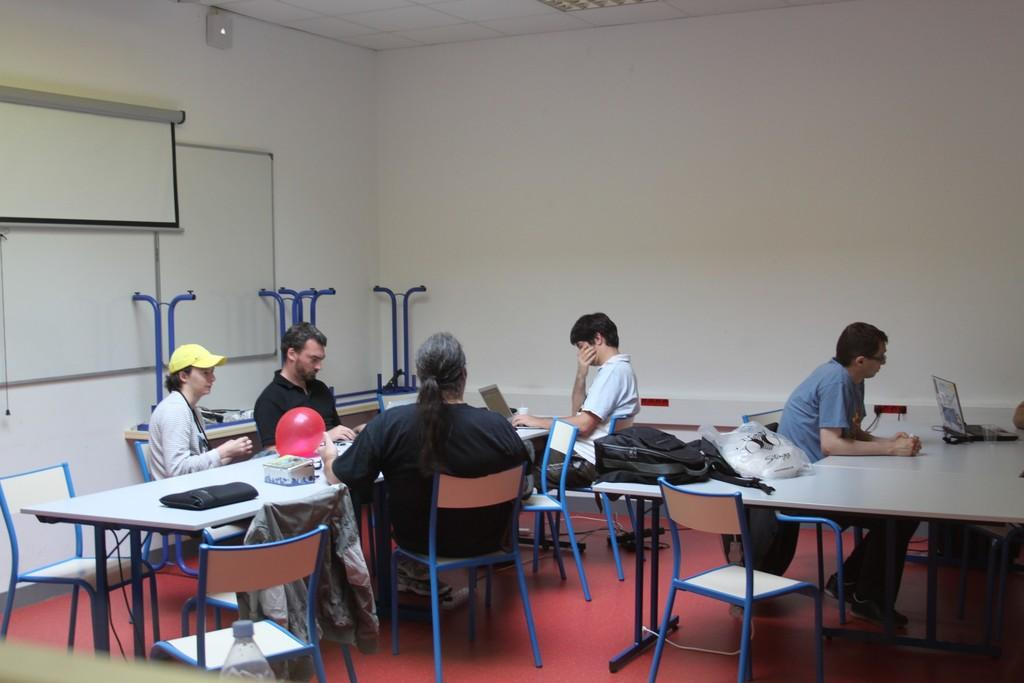What is the main subject of the image? The main subject of the image is a group of people. What are the people doing in the image? The people are seated on chairs in the image. What objects can be seen on a table in the image? There are laptops on a table in the image. What is the purpose of the projector screen in the image? The projector screen is likely used for presentations or displaying information. What is the whiteboard used for in the image? The whiteboard is likely used for writing or drawing information that can be easily seen by the group of people. How many rabbits can be seen saying good-bye to the group of people in the image? There are no rabbits present in the image, and no one is saying good-bye to the group of people. 